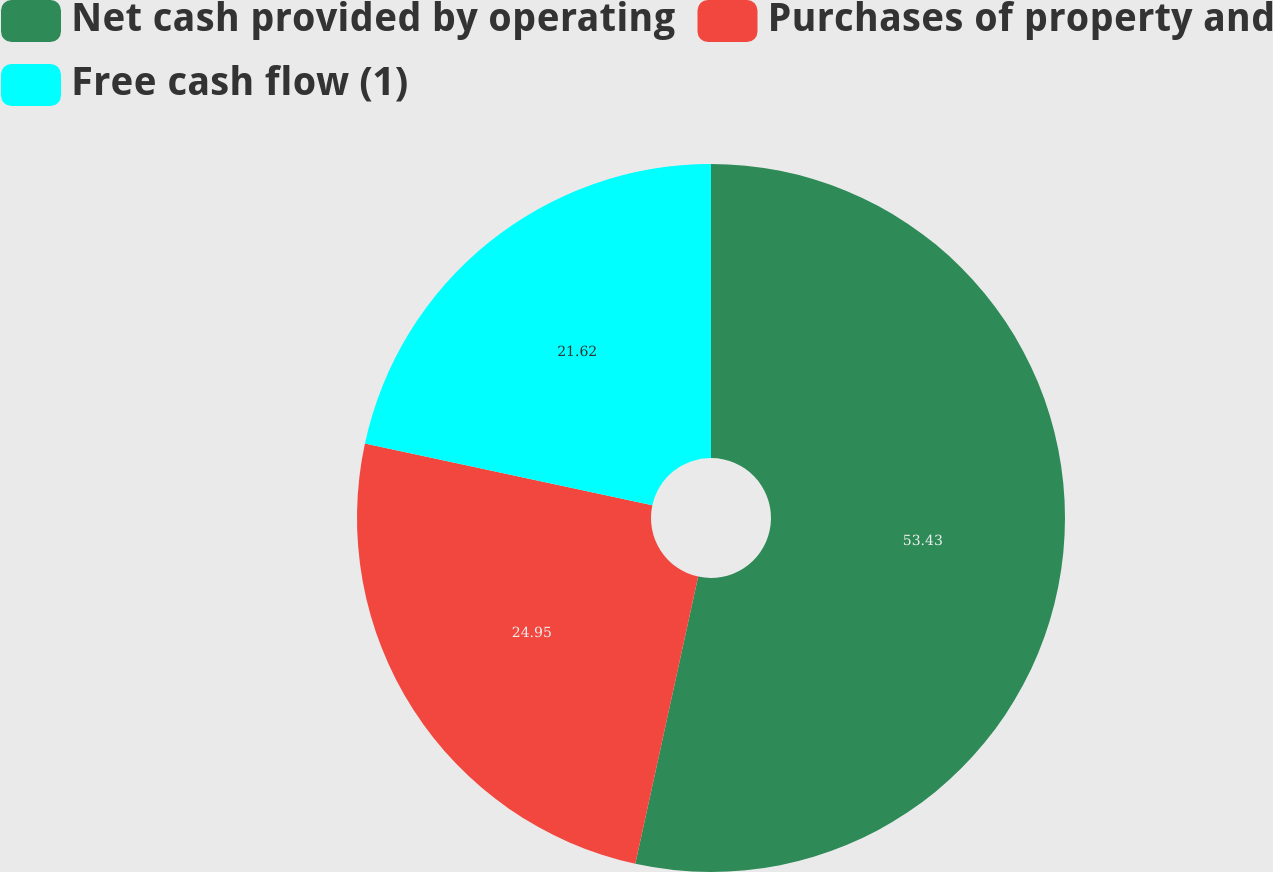Convert chart. <chart><loc_0><loc_0><loc_500><loc_500><pie_chart><fcel>Net cash provided by operating<fcel>Purchases of property and<fcel>Free cash flow (1)<nl><fcel>53.43%<fcel>24.95%<fcel>21.62%<nl></chart> 